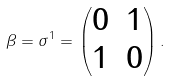<formula> <loc_0><loc_0><loc_500><loc_500>\beta = \sigma ^ { 1 } = \begin{pmatrix} 0 & 1 \\ 1 & 0 \end{pmatrix} .</formula> 